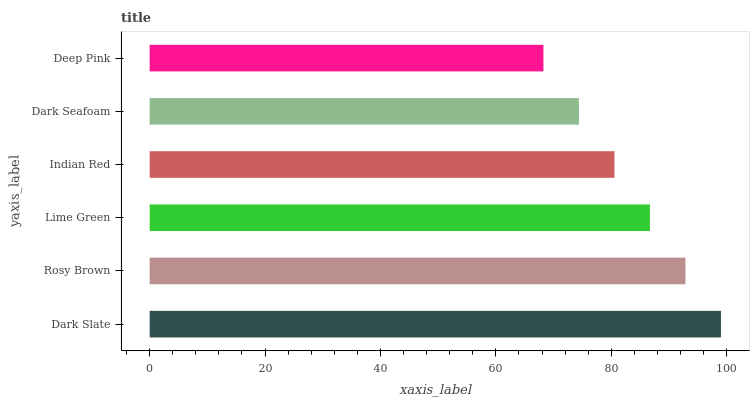Is Deep Pink the minimum?
Answer yes or no. Yes. Is Dark Slate the maximum?
Answer yes or no. Yes. Is Rosy Brown the minimum?
Answer yes or no. No. Is Rosy Brown the maximum?
Answer yes or no. No. Is Dark Slate greater than Rosy Brown?
Answer yes or no. Yes. Is Rosy Brown less than Dark Slate?
Answer yes or no. Yes. Is Rosy Brown greater than Dark Slate?
Answer yes or no. No. Is Dark Slate less than Rosy Brown?
Answer yes or no. No. Is Lime Green the high median?
Answer yes or no. Yes. Is Indian Red the low median?
Answer yes or no. Yes. Is Dark Seafoam the high median?
Answer yes or no. No. Is Deep Pink the low median?
Answer yes or no. No. 